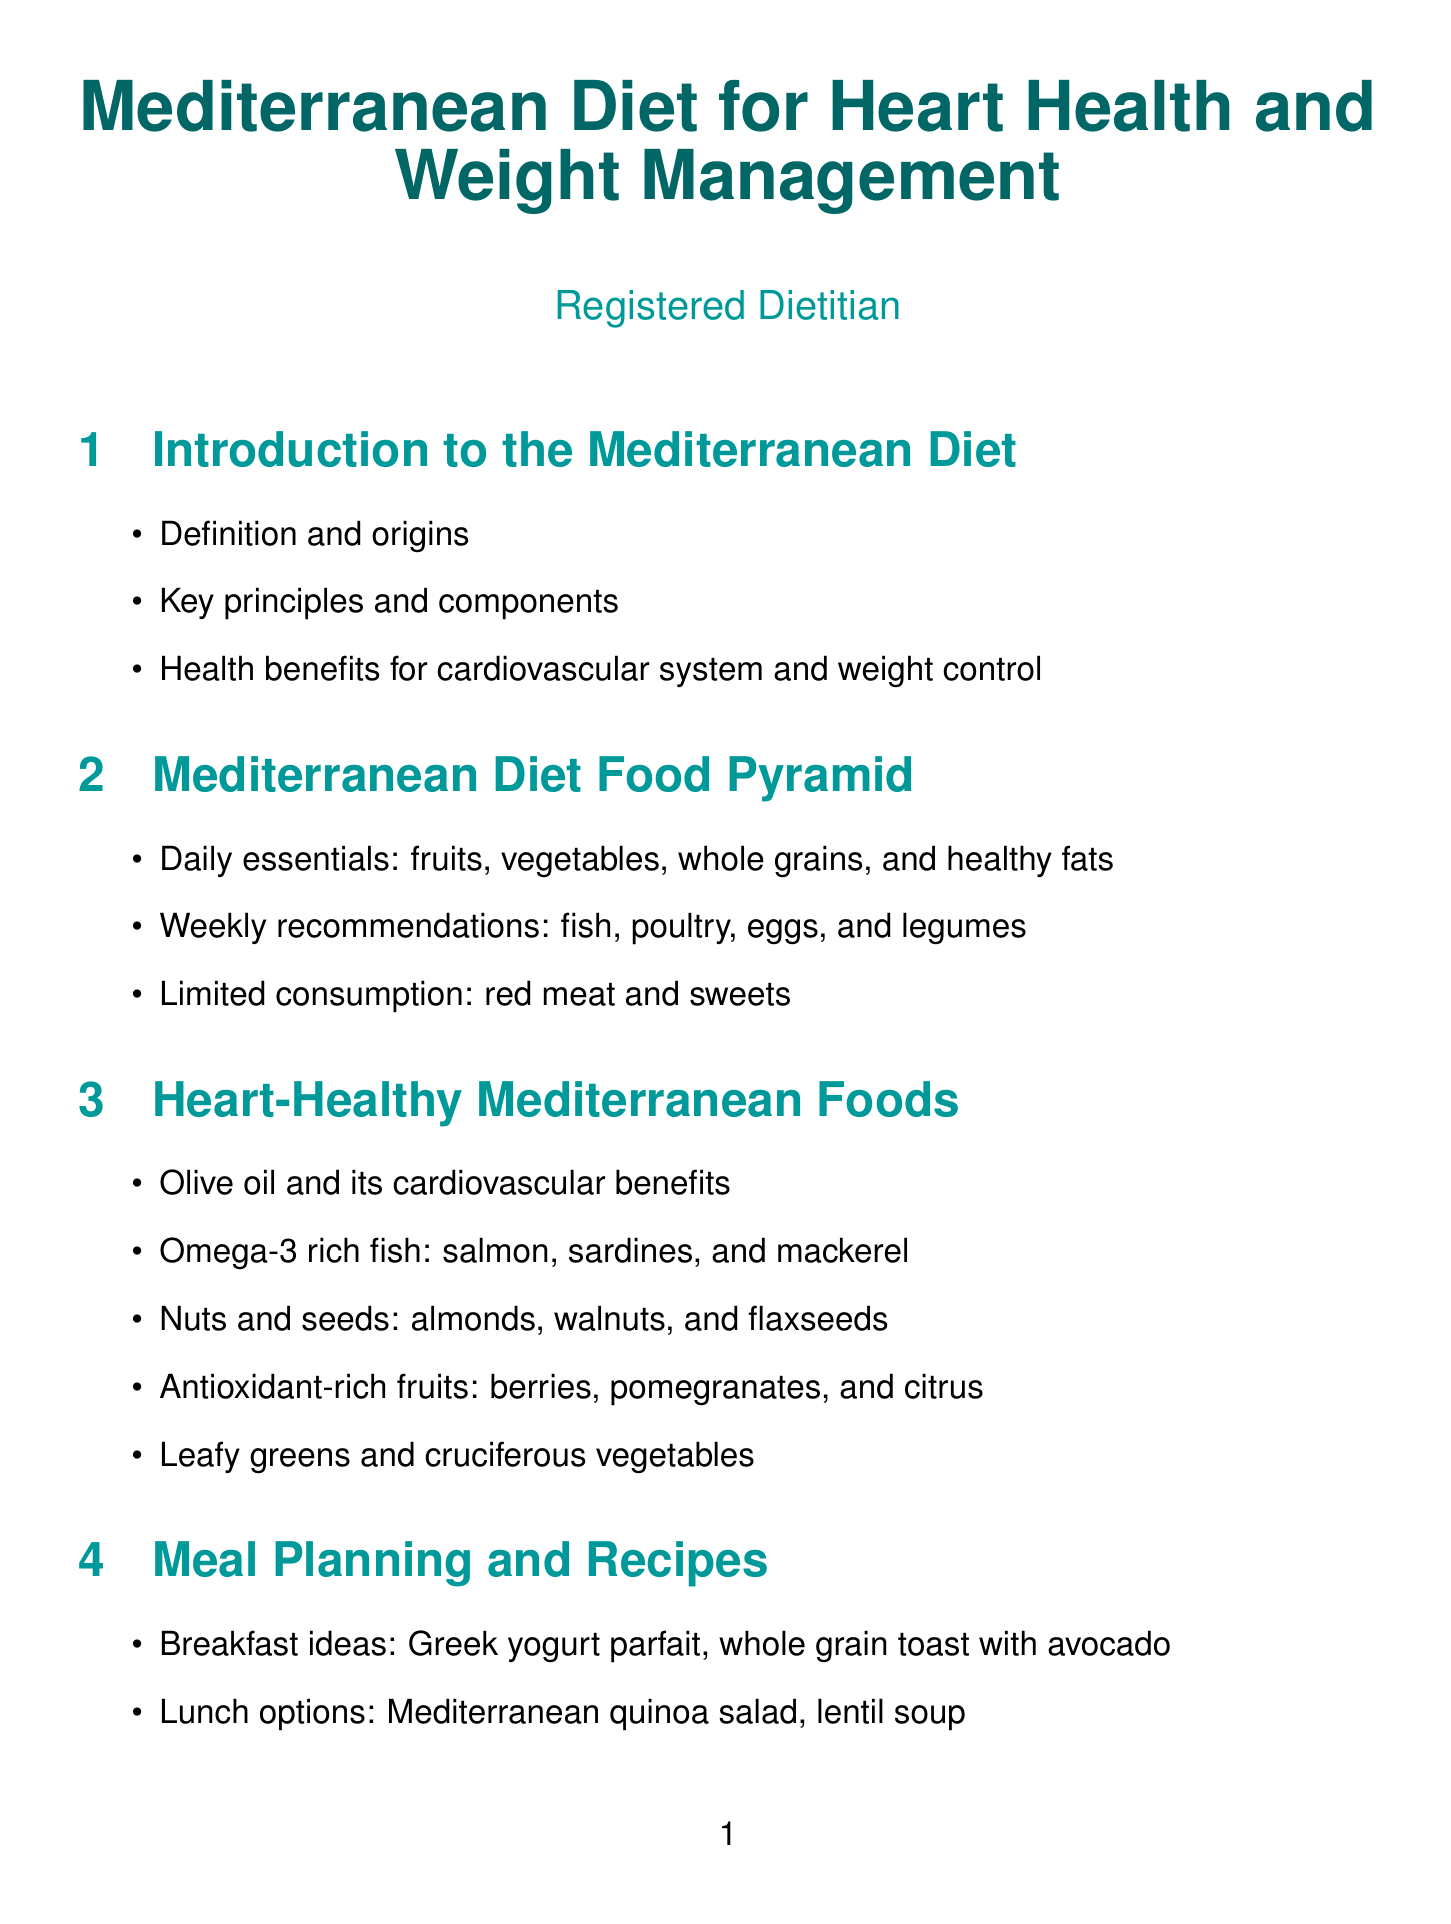What are the daily essentials in the Mediterranean diet? The daily essentials include fruits, vegetables, whole grains, and healthy fats as listed in the food pyramid section.
Answer: fruits, vegetables, whole grains, and healthy fats Which fish is rich in Omega-3? The document lists salmon, sardines, and mackerel as Omega-3 rich fish under heart-healthy Mediterranean foods.
Answer: salmon, sardines, and mackerel What is a breakfast idea mentioned in the meal planning section? The breakfast ideas include Greek yogurt parfait and whole grain toast with avocado from the meal planning and recipes section.
Answer: Greek yogurt parfait Name a key benefit of the Mediterranean diet. One of the health benefits listed is its impact on cardiovascular health, as stated in the introduction section.
Answer: cardiovascular health What practice is recommended for weight management in the diet? Mindful eating practices are recommended for weight management, as mentioned in the portion control and weight management section.
Answer: mindful eating practices How should you transition to a Mediterranean lifestyle? The manual suggests gradual changes in eating habits for transitioning, found in the corresponding section.
Answer: gradual changes in eating habits Which vegetable group is emphasized in the heart-healthy foods? Leafy greens and cruciferous vegetables are highlighted, found in the heart-healthy Mediterranean foods section.
Answer: leafy greens and cruciferous vegetables What is recommended for special populations in the diet? The document discusses adaptations for vegetarians and vegans as part of the Mediterranean diet for special populations.
Answer: adaptations for vegetarians and vegans What is one way to reduce food waste in Mediterranean cooking? Minimizing food waste is discussed under sustainability and environmental impact, highlighting this practice.
Answer: minimizing food waste 